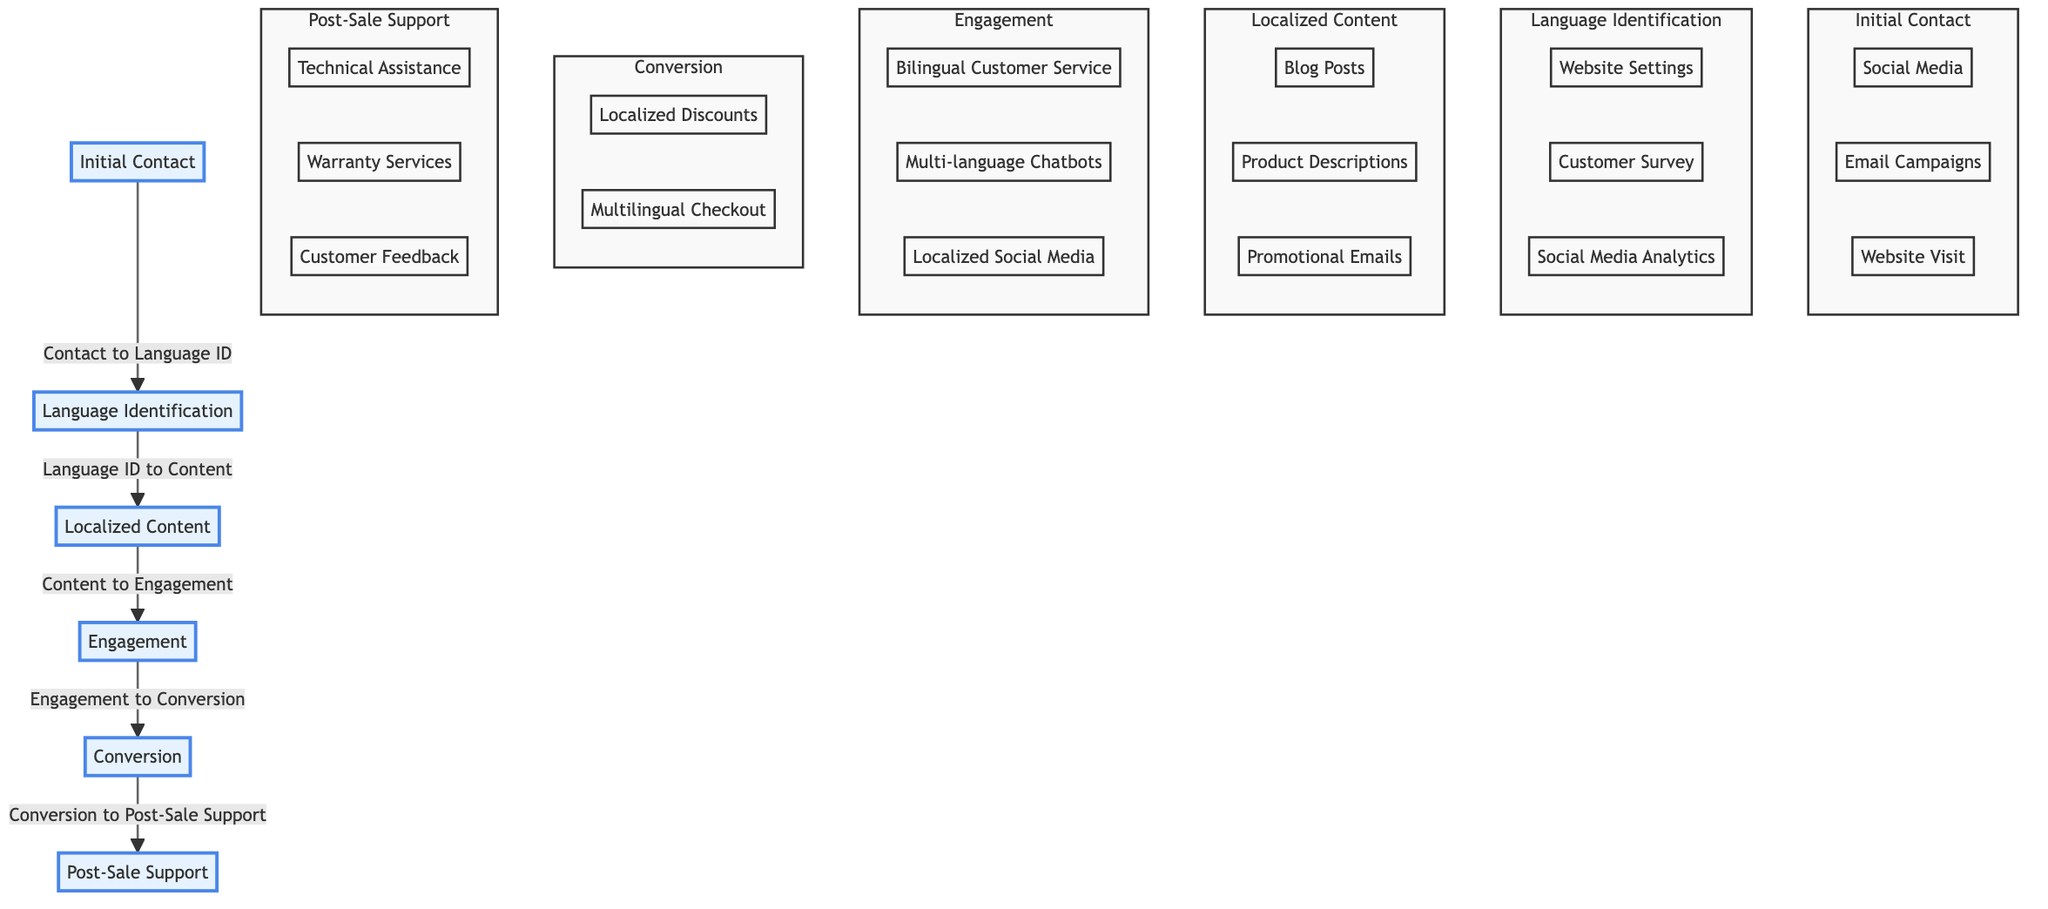What is the first node in the sales funnel? The diagram lists the nodes in order, starting with "Initial Contact" as the first node in the funnel.
Answer: Initial Contact How many channels are listed under the "Initial Contact" node? The "Initial Contact" node has three channels associated with it: "Social Media," "Email Campaigns," and "Website Visit." Therefore, the total count is three.
Answer: 3 What is the label of the node that follows "Language Identification"? By examining the connections in the diagram, the node "Localized Content" directly follows "Language Identification."
Answer: Localized Content Which type of support is provided in the "Post-Sale Support" node? The "Post-Sale Support" node lists several support types, including "Technical Assistance," "Warranty Services," and "Customer Feedback and Support." Any of these would qualify, but generally, it's classified as after-sales support.
Answer: Technical Assistance What is the last step in the sales funnel? Following the sequence of nodes, the last node mentioned in the funnel is "Post-Sale Support," which indicates the conclusion of the sales process.
Answer: Post-Sale Support Describe the connection between "Engagement" and "Conversion" nodes. The arrow linking these two nodes indicates a flow from "Engagement" to "Conversion," signifying that engaged customers are subsequently converted into paying customers. Thus, it depicts a direct relationship where engagement leads to conversion.
Answer: Engagement to Conversion What are the methods used for language identification? The "Language Identification" node details three methods: "Website Language Settings," "Customer Survey," and "Social Media Analytics," indicating the options available for identifying customer language preferences.
Answer: Website Language Settings, Customer Survey, Social Media Analytics How many total nodes are represented in the diagram? The diagram includes six distinct nodes: "Initial Contact," "Language Identification," "Localized Content," "Engagement," "Conversion," and "Post-Sale Support." By counting these, we determine there are six nodes in total.
Answer: 6 What activities are included in the "Engagement" node? Upon reviewing the "Engagement" node, it includes three activities: "Bilingual Customer Service," "Multi-language Chatbots," and "Localized Social Media Campaigns." This shows the approach to keeping customers engaged through multilingual services.
Answer: Bilingual Customer Service, Multi-language Chatbots, Localized Social Media Campaigns 